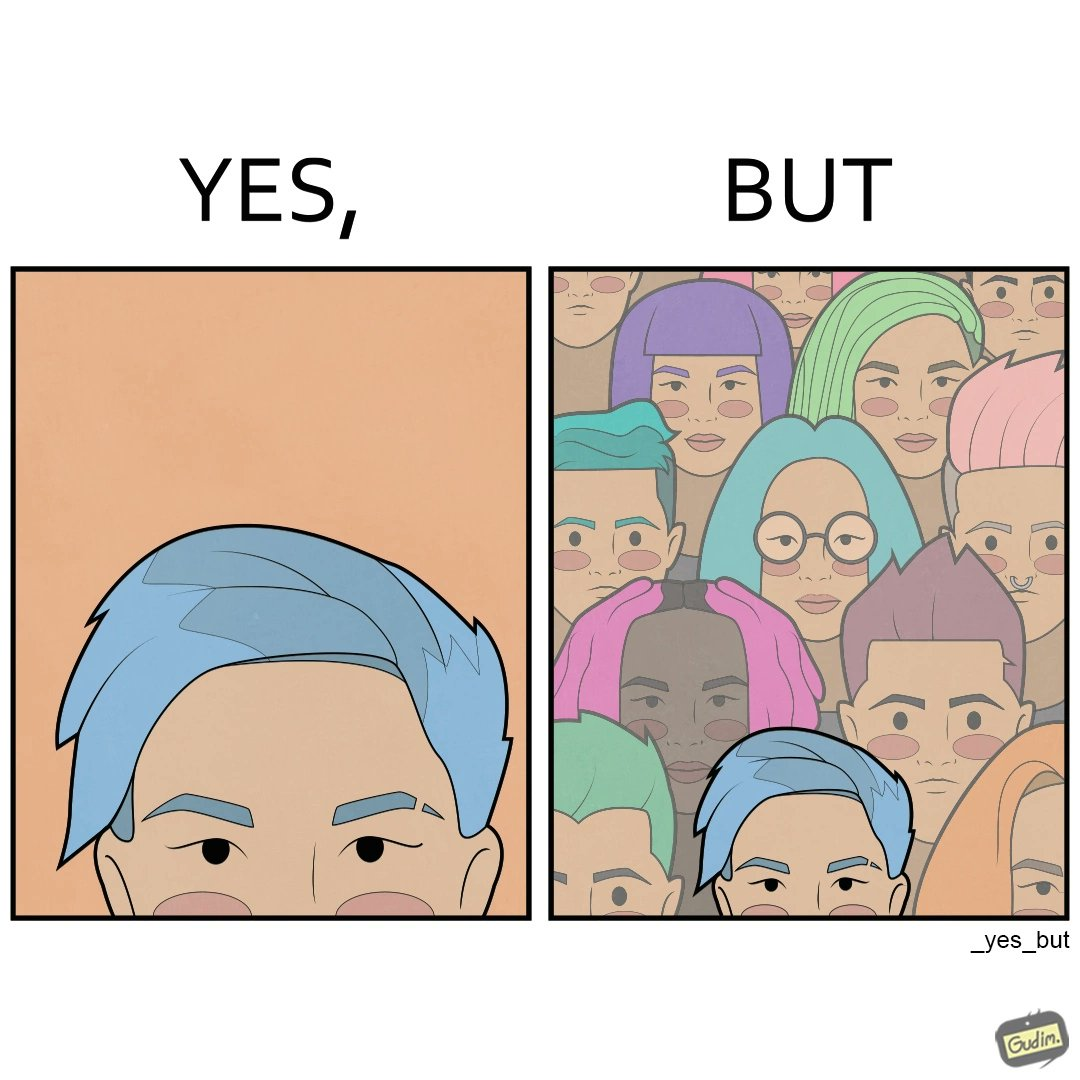Describe what you see in the left and right parts of this image. In the left part of the image: a person with hair dyed blue. In the right part of the image: a group of people having hair dyed in different colors. 